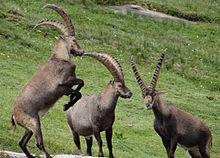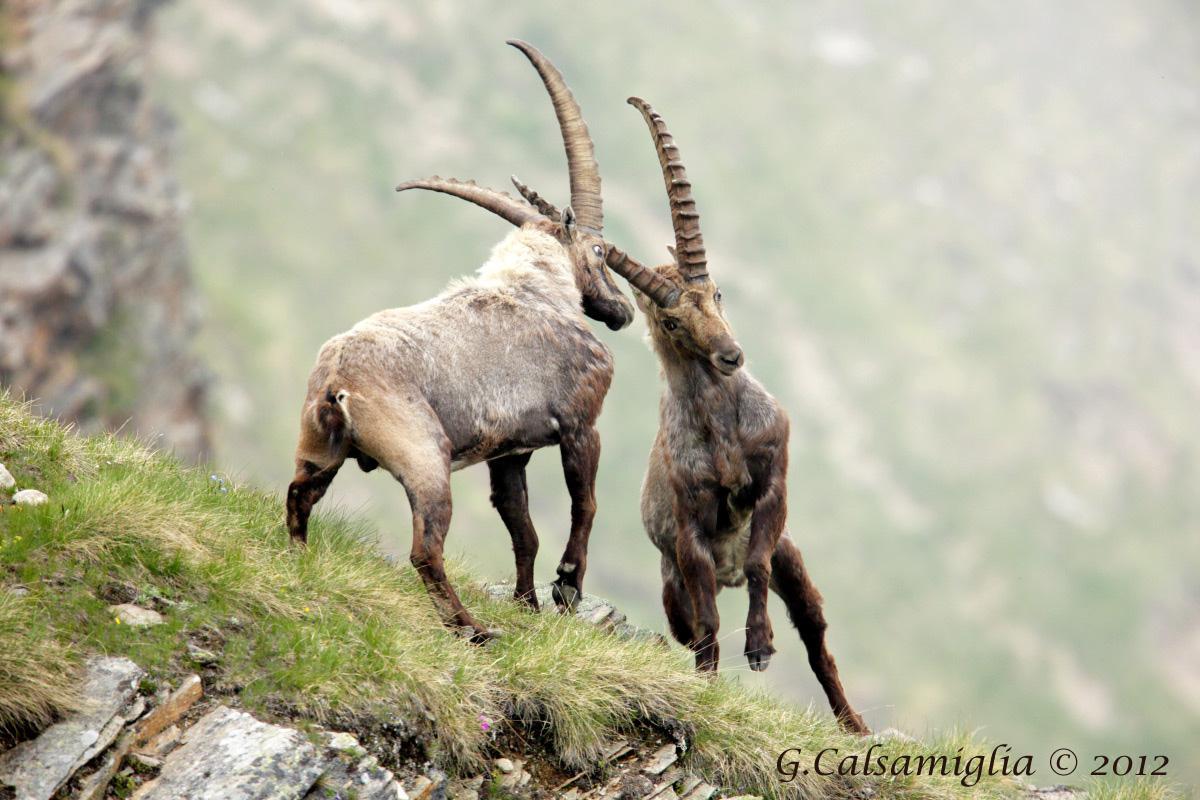The first image is the image on the left, the second image is the image on the right. Given the left and right images, does the statement "Two animals are butting heads in the image on the right." hold true? Answer yes or no. Yes. The first image is the image on the left, the second image is the image on the right. Evaluate the accuracy of this statement regarding the images: "An image includes a rearing horned animal, with both its front legs high off the ground.". Is it true? Answer yes or no. Yes. 